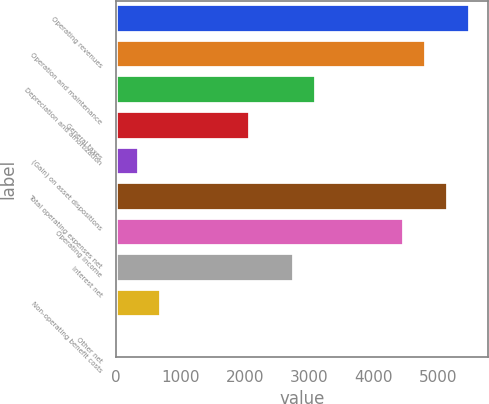<chart> <loc_0><loc_0><loc_500><loc_500><bar_chart><fcel>Operating revenues<fcel>Operation and maintenance<fcel>Depreciation and amortization<fcel>General taxes<fcel>(Gain) on asset dispositions<fcel>Total operating expenses net<fcel>Operating income<fcel>Interest net<fcel>Non-operating benefit costs<fcel>Other net<nl><fcel>5492.6<fcel>4808.4<fcel>3097.9<fcel>2071.6<fcel>361.1<fcel>5150.5<fcel>4466.3<fcel>2755.8<fcel>703.2<fcel>19<nl></chart> 